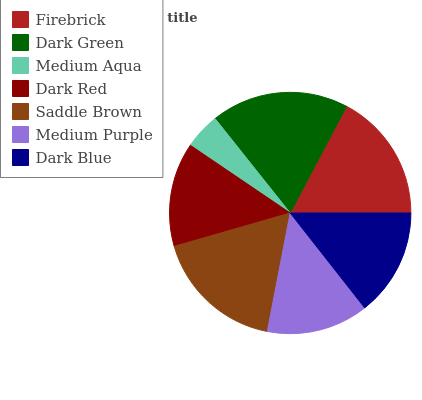Is Medium Aqua the minimum?
Answer yes or no. Yes. Is Dark Green the maximum?
Answer yes or no. Yes. Is Dark Green the minimum?
Answer yes or no. No. Is Medium Aqua the maximum?
Answer yes or no. No. Is Dark Green greater than Medium Aqua?
Answer yes or no. Yes. Is Medium Aqua less than Dark Green?
Answer yes or no. Yes. Is Medium Aqua greater than Dark Green?
Answer yes or no. No. Is Dark Green less than Medium Aqua?
Answer yes or no. No. Is Dark Blue the high median?
Answer yes or no. Yes. Is Dark Blue the low median?
Answer yes or no. Yes. Is Dark Red the high median?
Answer yes or no. No. Is Medium Purple the low median?
Answer yes or no. No. 